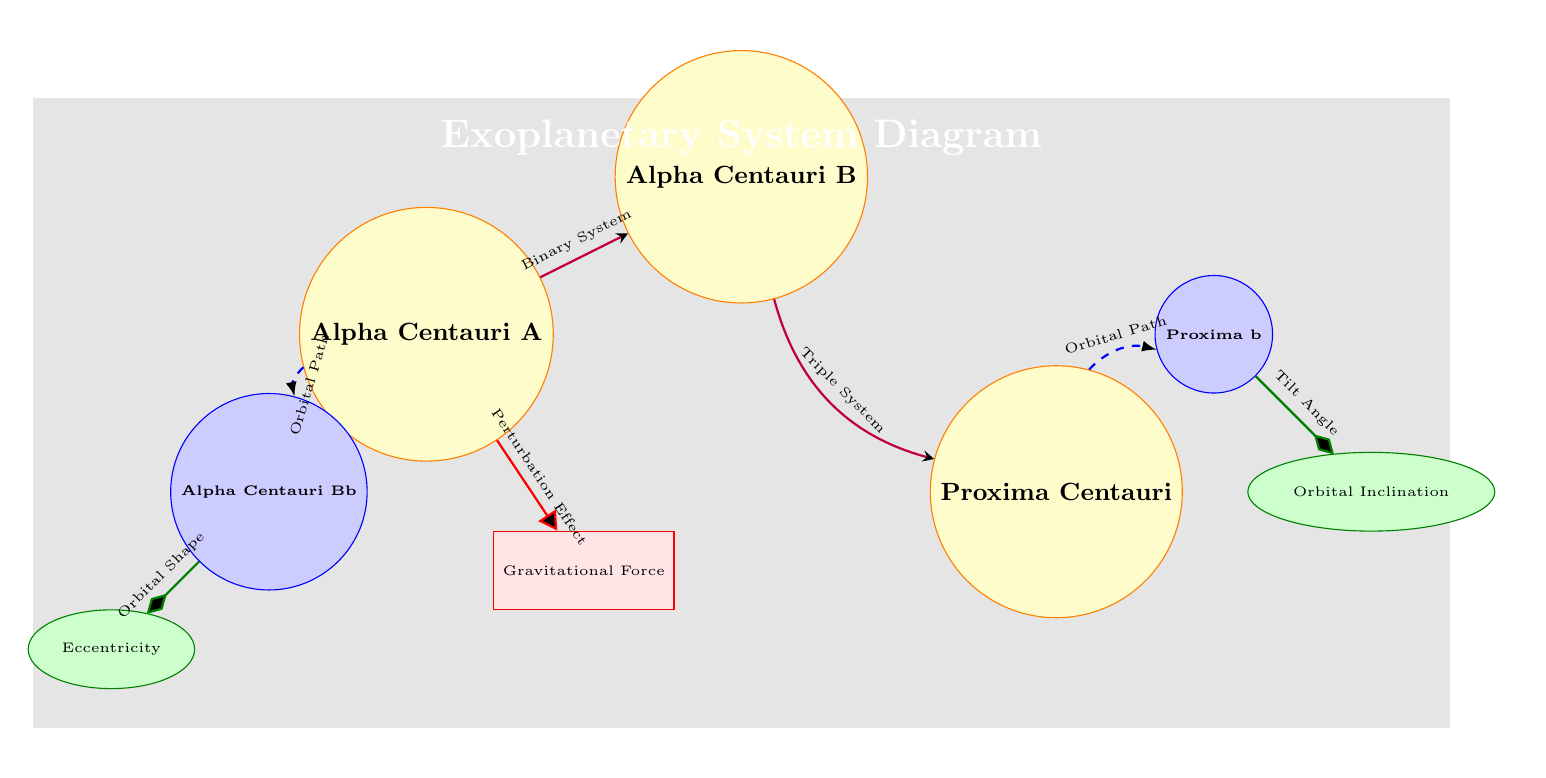What's the name of the closest star system shown? The diagram displays three stars, and the one closest to Earth is Proxima Centauri, which is indicated at the position furthest to the right.
Answer: Proxima Centauri How many exoplanets are depicted in the diagram? The diagram illustrates two exoplanets, labeled Proxima b and Alpha Centauri Bb, positioned relative to their respective star systems.
Answer: 2 Which star has a perturbation effect related to a gravitational force? The diagram includes a directed edge from Alpha Centauri A to the Gravitational Force box, indicating that it exerts a perturbation effect.
Answer: Alpha Centauri A What is the orbital characteristic represented by the ellipse associated with Alpha Centauri Bb? The diagram shows a directed edge from Alpha Centauri Bb to the Eccentricity box, suggesting that this exoplanet's orbital characteristic is its eccentricity.
Answer: Eccentricity What type of stellar system is formed by Alpha Centauri A and Alpha Centauri B? The diagram indicates a relationship edge between Alpha Centauri A and Alpha Centauri B labeled as a Binary System, signifying that these stars are in a binary configuration.
Answer: Binary System Which gravitational interaction affects Proxima b? The diagram illustrates a dashed arrow from Proxima Centauri to Proxima b labeled as Orbital Path, which indicates the gravitational interaction affecting Proxima b's trajectory.
Answer: Orbital Path What is the orbital inclination of Proxima b? The diagram shows a directed edge from Proxima b to the Orbital Inclination box, suggesting that this parameter indicates the tilt in Proxima b's orbit.
Answer: Tilt Angle How do Alpha Centauri A and Alpha Centauri B relate to Proxima Centauri? The diagram represents a relationship with a bend right arrow from Alpha Centauri B to Proxima Centauri labeled Triple System, indicating their combined gravitational influence.
Answer: Triple System 